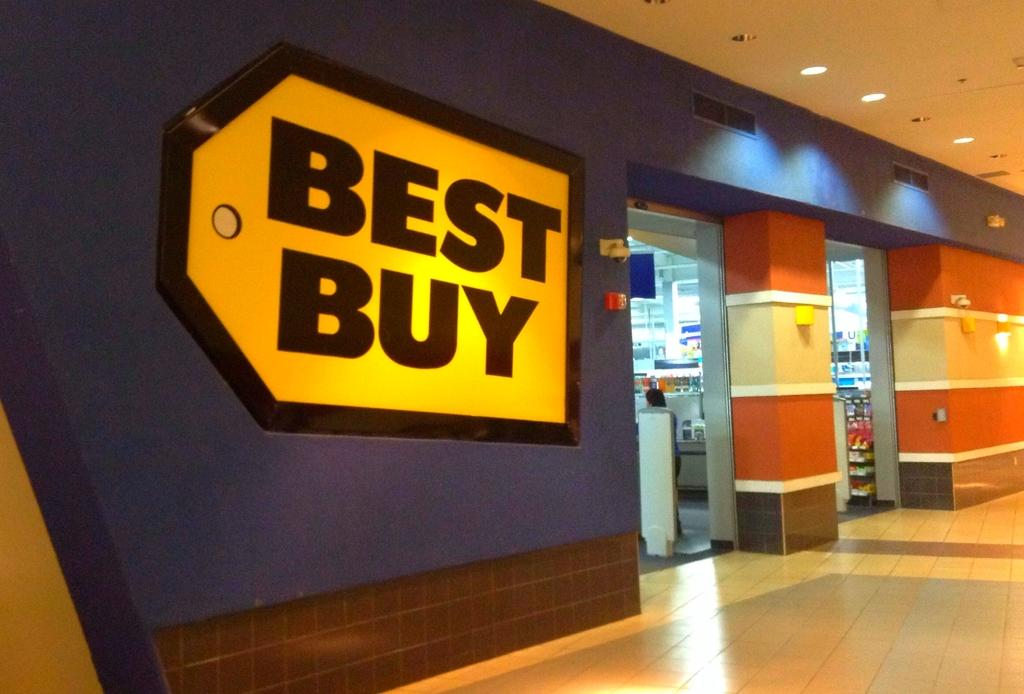<image>
Summarize the visual content of the image. The exterior of a Best Buy store inside a shopping center. 